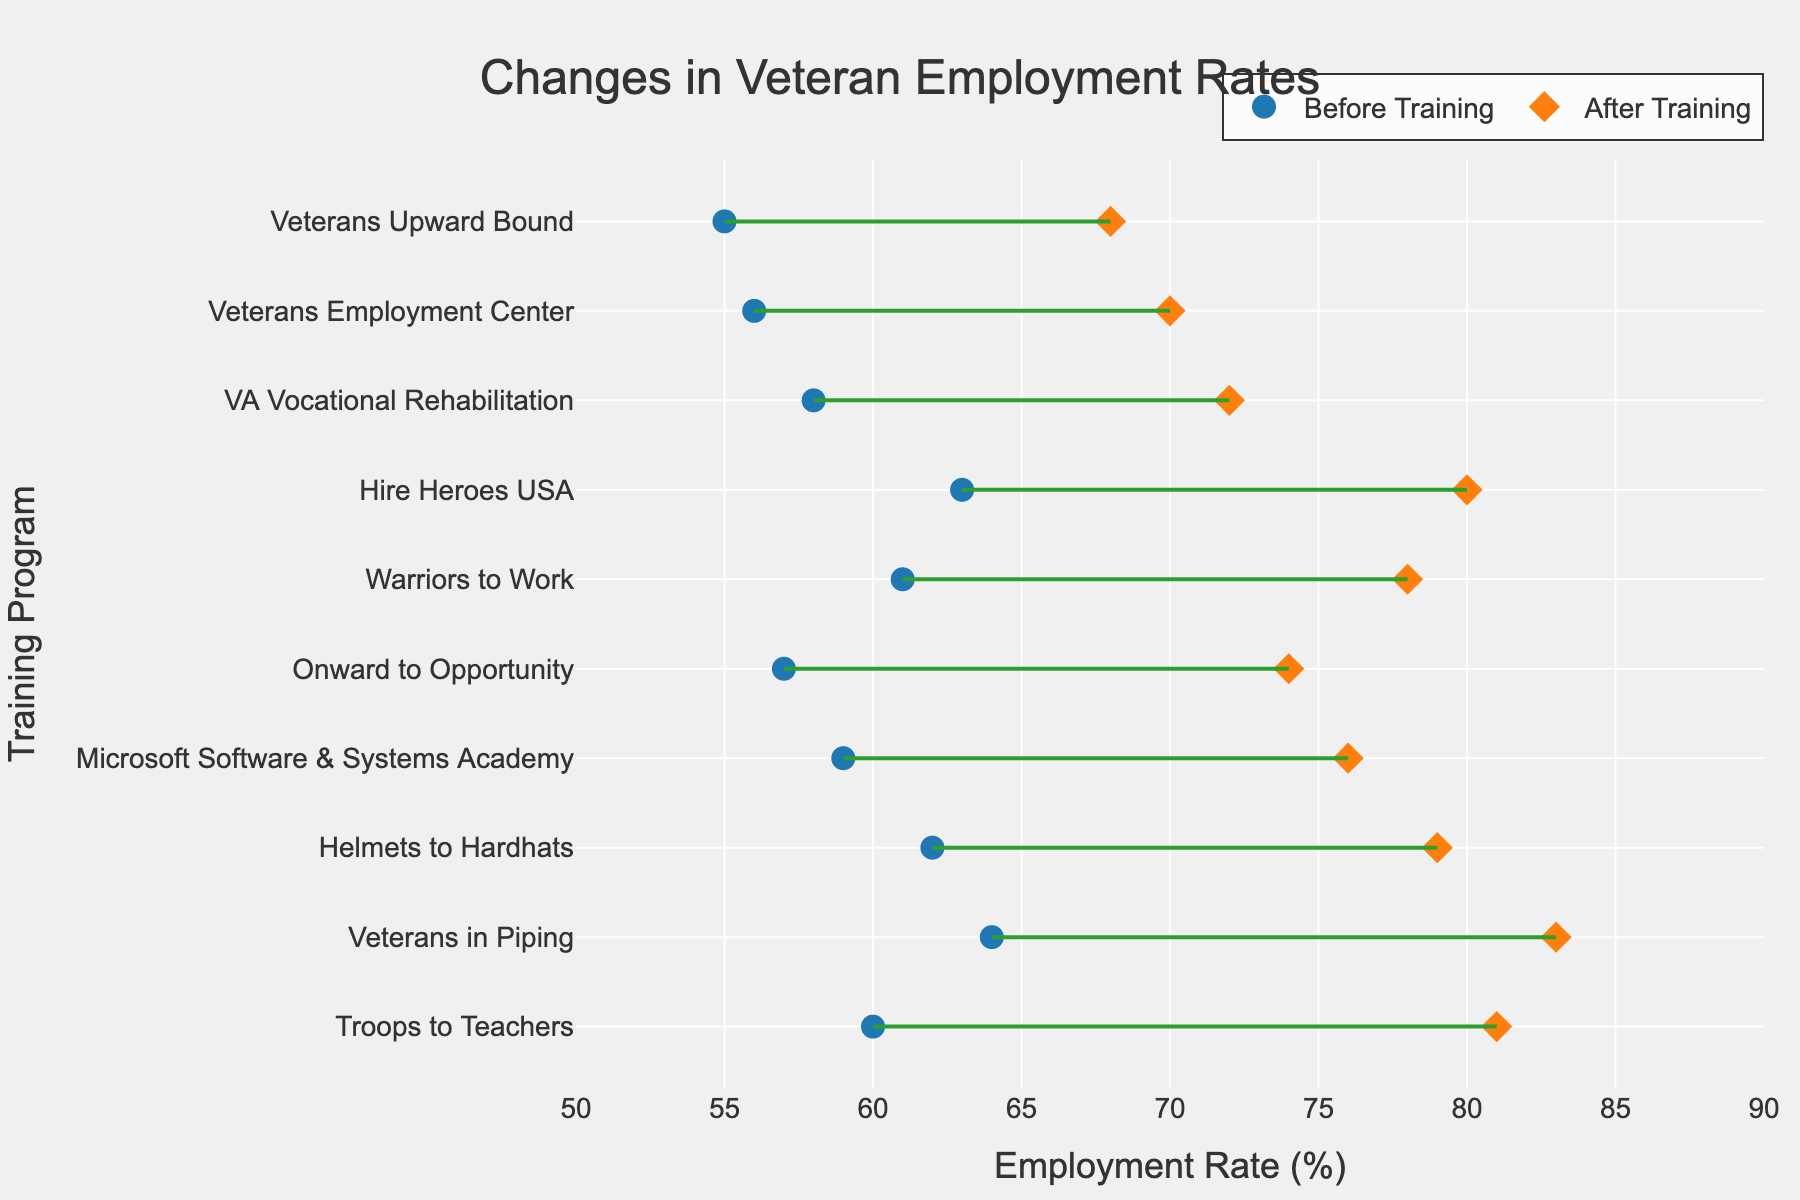What is the title of the plot? The title of the plot is usually found at the top of the figure. Here, it reads 'Changes in Veteran Employment Rates'.
Answer: Changes in Veteran Employment Rates What are the colors used for 'Before Training' and 'After Training' markers? The 'Before Training' markers are blue and the 'After Training' markers are orange. These colors help visually differentiate between the two data sets.
Answer: Blue and Orange Which training program shows the highest employment rate after training? By looking at the orange markers (indicating 'After Training'), we can see that 'Troops to Teachers' has the highest employment rate at 81%.
Answer: Troops to Teachers What is the range of the x-axis? The x-axis range is indicated at the bottom of the figure, it spans from 50% to 90%. This sets the scope for the employment rates depicted.
Answer: 50% to 90% Which program has the biggest improvement in employment rate? To determine this, look for the largest horizontal distance between the 'Before Training' and 'After Training' markers. 'Veterans in Piping' shows the biggest improvement, increasing from 64% to 83%, a difference of 19 percentage points.
Answer: Veterans in Piping What is the average employment rate after training across all programs? Sum up all 'After Training' values (72 + 79 + 68 + 81 + 83 + 76 + 74 + 78 + 70 + 80) which equals 761, then divide by the number of programs (10). Therefore, 761/10 = 76.1%.
Answer: 76.1% Which two programs have the smallest change in employment rates? By comparing the lengths of the connecting lines for each program, 'Veterans Upward Bound' and 'Veterans Employment Center' show the smallest change.
Answer: Veterans Upward Bound and Veterans Employment Center How does the 'Before Training' rate for 'Helmets to Hardhats' compare with 'Hire Heroes USA'? Compare the blue markers for these two programs; 'Helmets to Hardhats' has 62% while 'Hire Heroes USA' has 63%. Therefore, 'Hire Heroes USA' has a slightly higher 'Before Training' rate.
Answer: Hire Heroes USA is slightly higher Is there any program whose employment rate surpasses 80% after training? Scan the orange markers (After Training). Both 'Troops to Teachers' and 'Veterans in Piping' surpass the 80% mark with rates of 81% and 83%, respectively.
Answer: Yes, two programs 